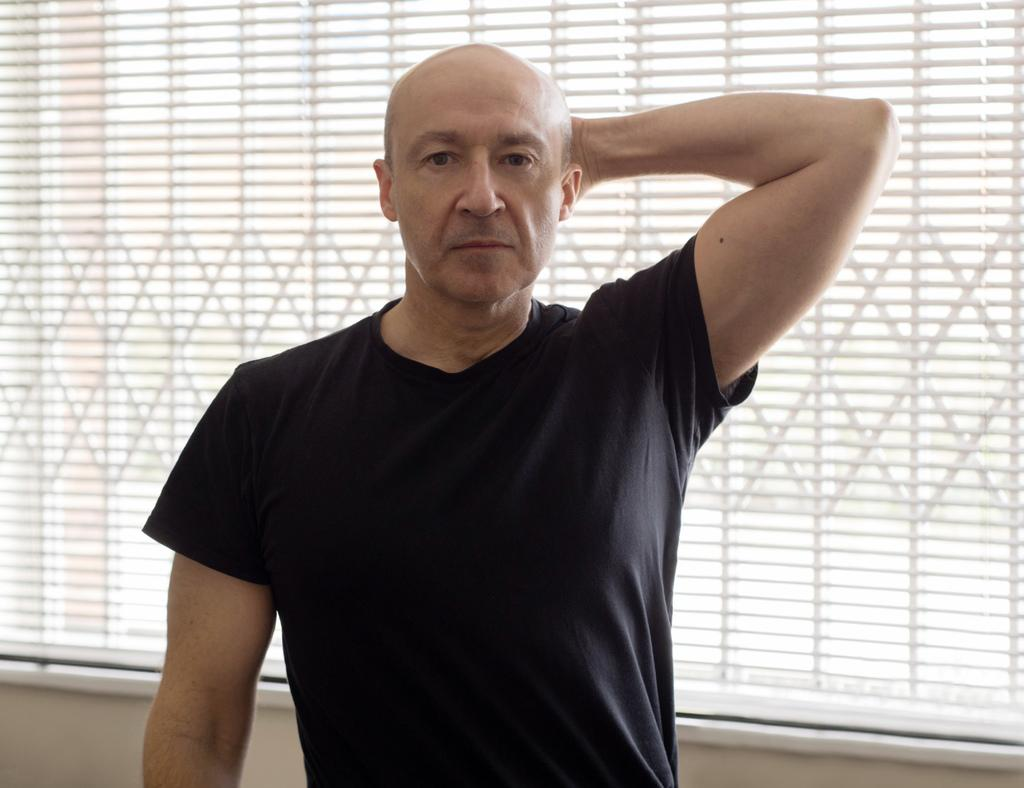What is the main subject of the image? There is a person in the image. What is the person wearing? The person is wearing a black T-shirt. What is the person's posture in the image? The person is standing. What can be seen in the background of the image? There is a window in the background of the image. What type of minister is standing on the stage in the image? There is no minister or stage present in the image; it only features a person standing. What nerve is visible in the image? There is no nerve visible in the image; it only features a person standing and a window in the background. 